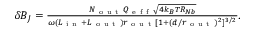<formula> <loc_0><loc_0><loc_500><loc_500>\begin{array} { r } { \delta B _ { J } = \frac { N _ { o u t } Q _ { e f f } \sqrt { 4 k _ { B } T R _ { N b } } } { \omega ( L _ { i n } + L _ { o u t } ) r _ { o u t } [ 1 + ( d / r _ { o u t } ) ^ { 2 } ] ^ { 3 / 2 } } . } \end{array}</formula> 